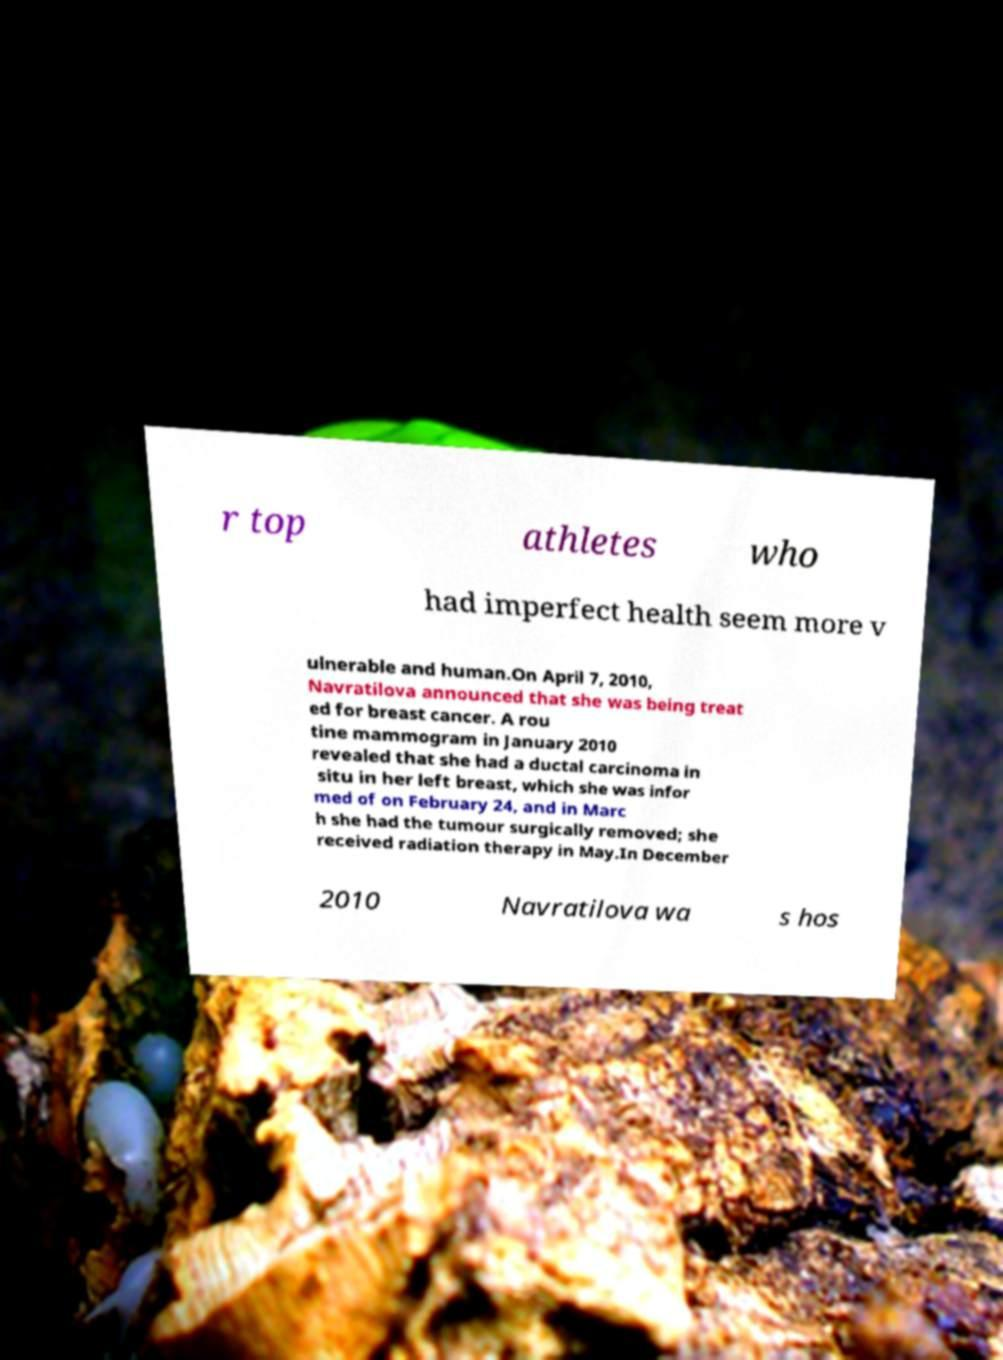Can you accurately transcribe the text from the provided image for me? r top athletes who had imperfect health seem more v ulnerable and human.On April 7, 2010, Navratilova announced that she was being treat ed for breast cancer. A rou tine mammogram in January 2010 revealed that she had a ductal carcinoma in situ in her left breast, which she was infor med of on February 24, and in Marc h she had the tumour surgically removed; she received radiation therapy in May.In December 2010 Navratilova wa s hos 